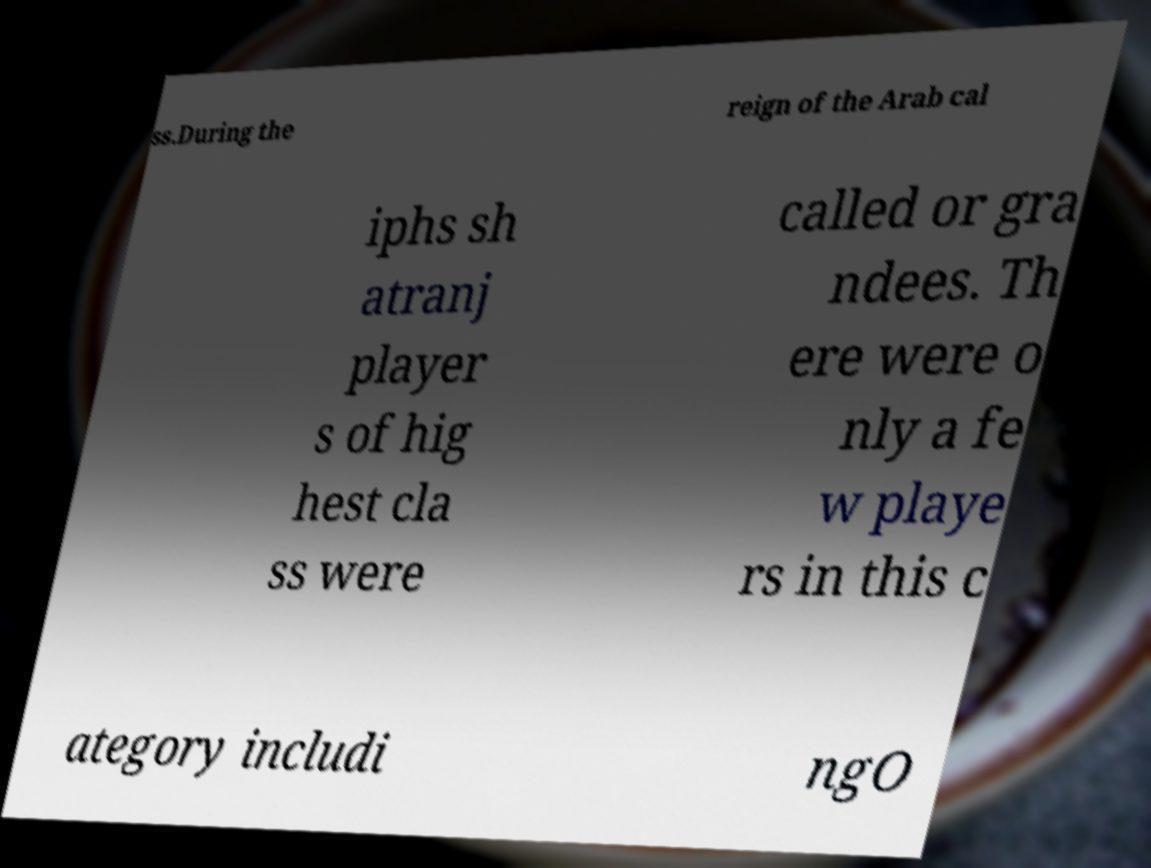Can you accurately transcribe the text from the provided image for me? ss.During the reign of the Arab cal iphs sh atranj player s of hig hest cla ss were called or gra ndees. Th ere were o nly a fe w playe rs in this c ategory includi ngO 